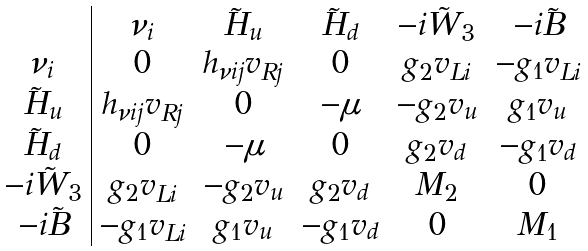<formula> <loc_0><loc_0><loc_500><loc_500>\begin{array} { c | c c c c c c c c } & { \nu } _ { i } & \tilde { H } _ { u } & \tilde { H } _ { d } & - i \tilde { W } _ { 3 } & - i \tilde { B } \\ { \nu } _ { i } & 0 & h _ { \nu i j } v _ { R j } & 0 & g _ { 2 } v _ { L i } & - g _ { 1 } v _ { L i } \\ \tilde { H } _ { u } & h _ { \nu i j } v _ { R j } & 0 & - \mu & - g _ { 2 } v _ { u } & g _ { 1 } v _ { u } \\ \tilde { H } _ { d } & 0 & - \mu & 0 & g _ { 2 } v _ { d } & - g _ { 1 } v _ { d } \\ - i \tilde { W } _ { 3 } & g _ { 2 } v _ { L i } & - g _ { 2 } v _ { u } & g _ { 2 } v _ { d } & M _ { 2 } & 0 \\ - i \tilde { B } & - g _ { 1 } v _ { L i } & g _ { 1 } v _ { u } & - g _ { 1 } v _ { d } & 0 & M _ { 1 } \end{array} \,</formula> 